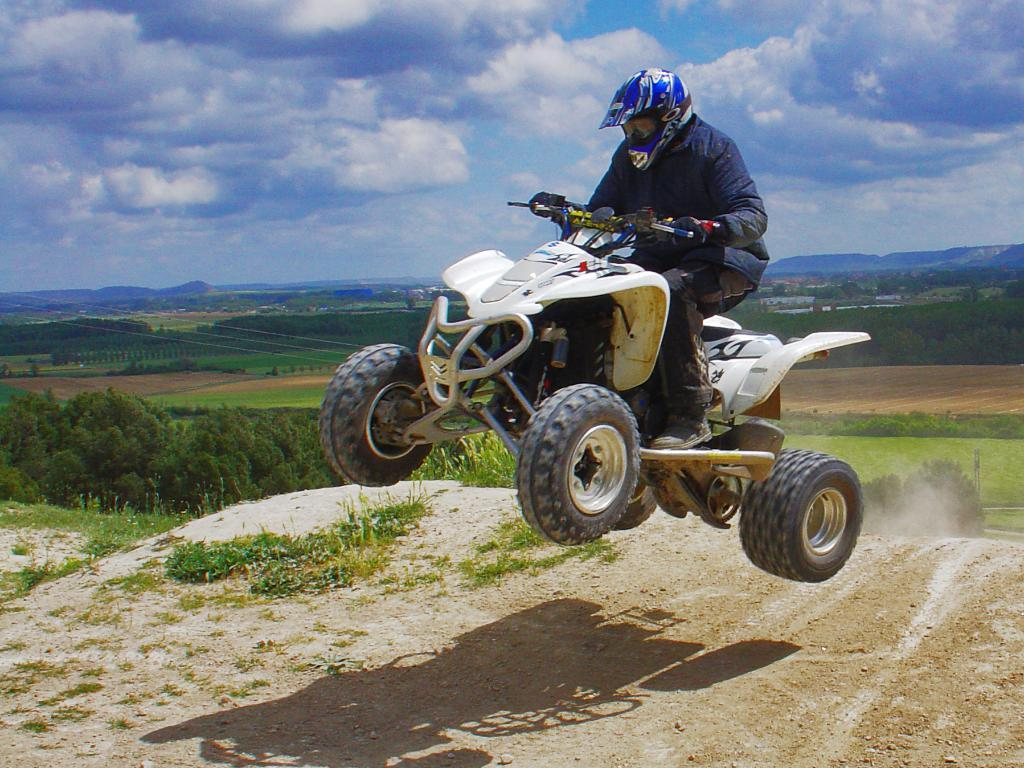What is the main subject of the image? There is a person riding a motorcycle in the image. What type of natural environment is visible in the image? There are trees, grass, and a mountain in the image. What part of the ground can be seen in the image? The ground is visible in the image. What is visible above the ground in the image? The sky is visible in the image. What type of dress is the person wearing while riding the motorcycle in the image? There is no dress visible in the image; the person is wearing motorcycle gear or regular clothing. 